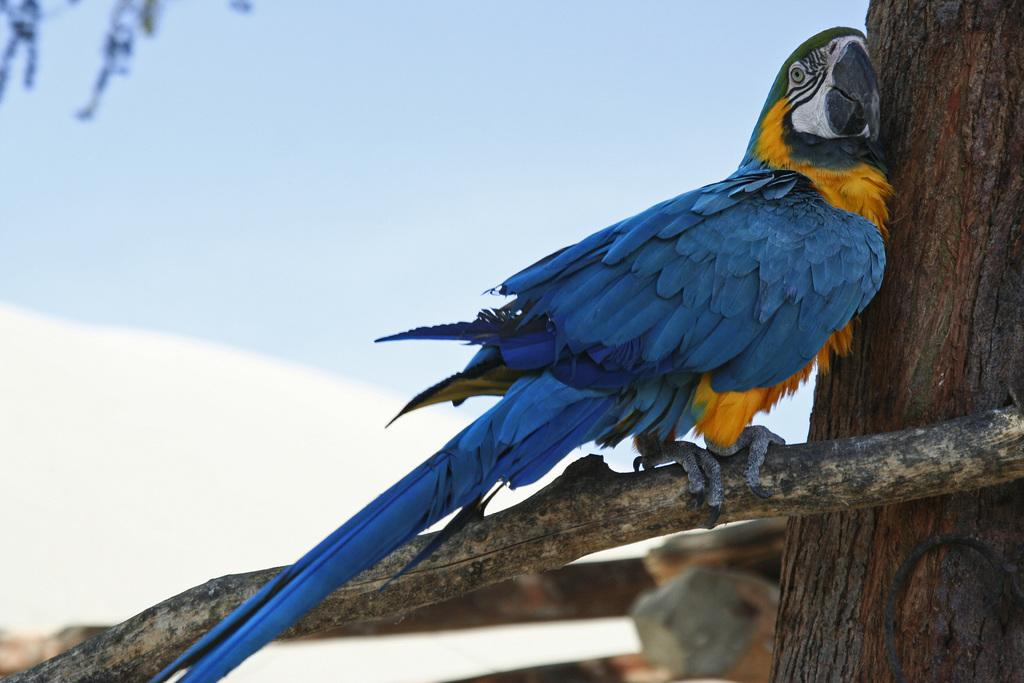What animal is in the foreground of the image? There is a parrot in the foreground of the image. What is the parrot sitting on? The parrot is sitting on a tree branch. What part of the tree is visible in the image? There is a tree trunk in the foreground of the image. What can be seen in the background of the image? The sky is visible in the background of the image. When was the image taken? The image was taken during the day. What type of drink is the parrot holding in its beak during the rainstorm? There is no rainstorm present in the image, and the parrot is not holding any drink in its beak. 